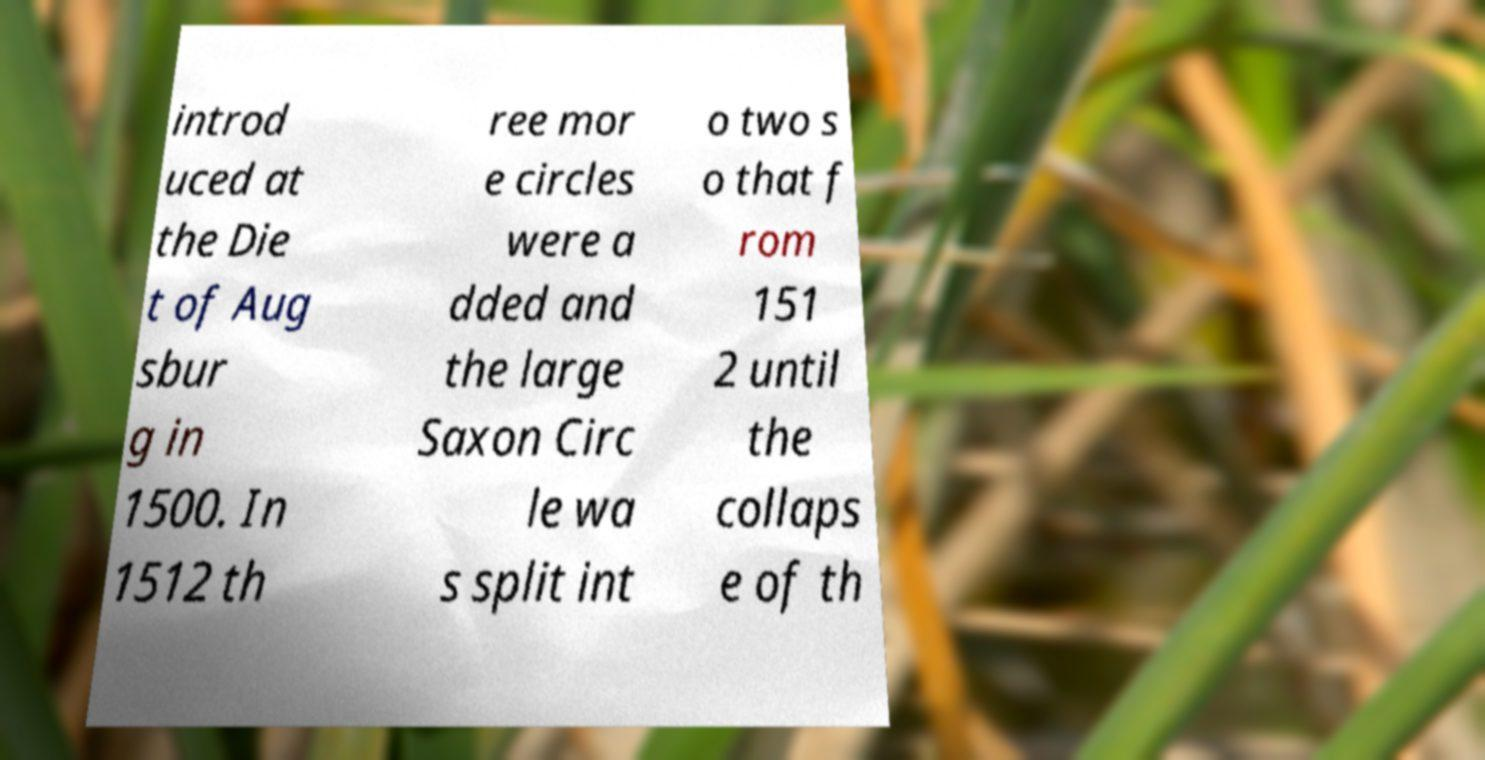Please read and relay the text visible in this image. What does it say? introd uced at the Die t of Aug sbur g in 1500. In 1512 th ree mor e circles were a dded and the large Saxon Circ le wa s split int o two s o that f rom 151 2 until the collaps e of th 